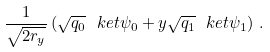Convert formula to latex. <formula><loc_0><loc_0><loc_500><loc_500>\frac { 1 } { \sqrt { 2 r _ { y } } } \left ( \sqrt { q _ { 0 } } \ k e t { \psi _ { 0 } } + y \sqrt { q _ { 1 } } \ k e t { \psi _ { 1 } } \right ) \, .</formula> 